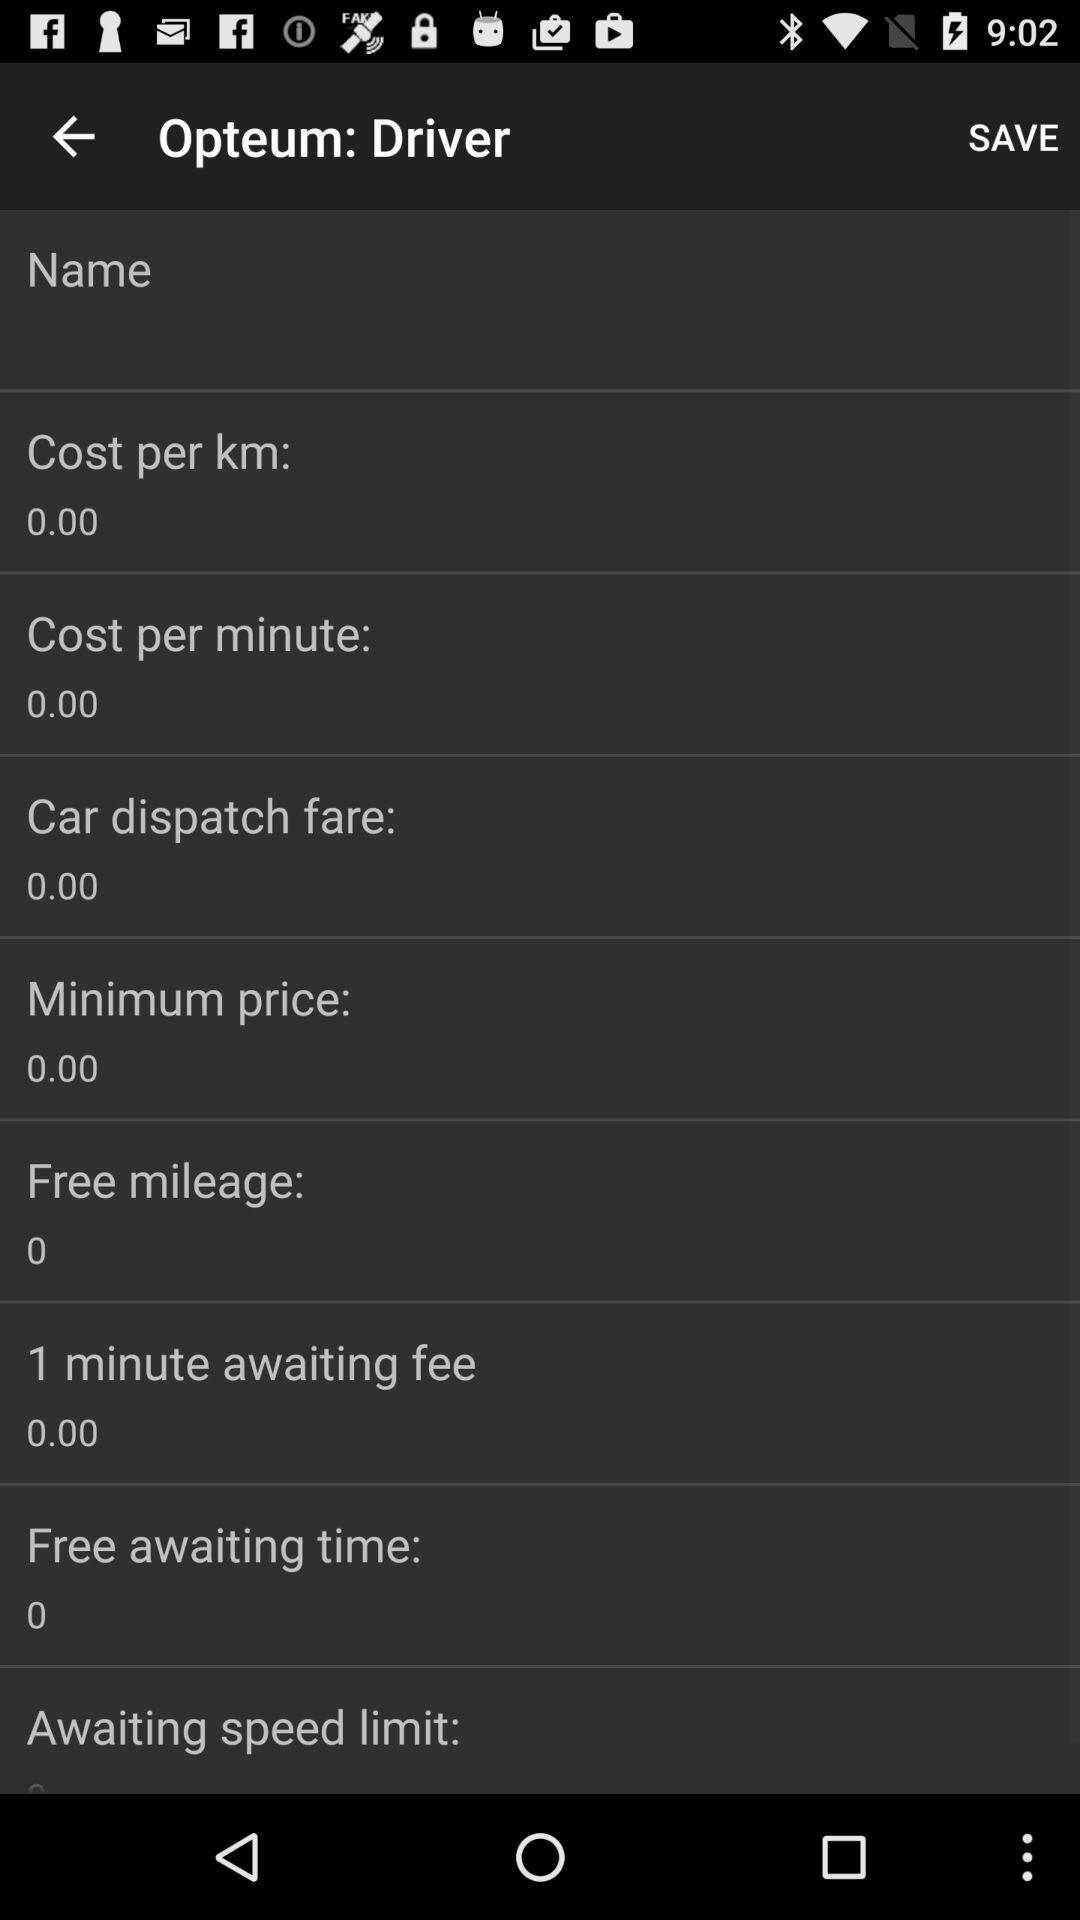What is the minimum price? The minimum price is 0. 